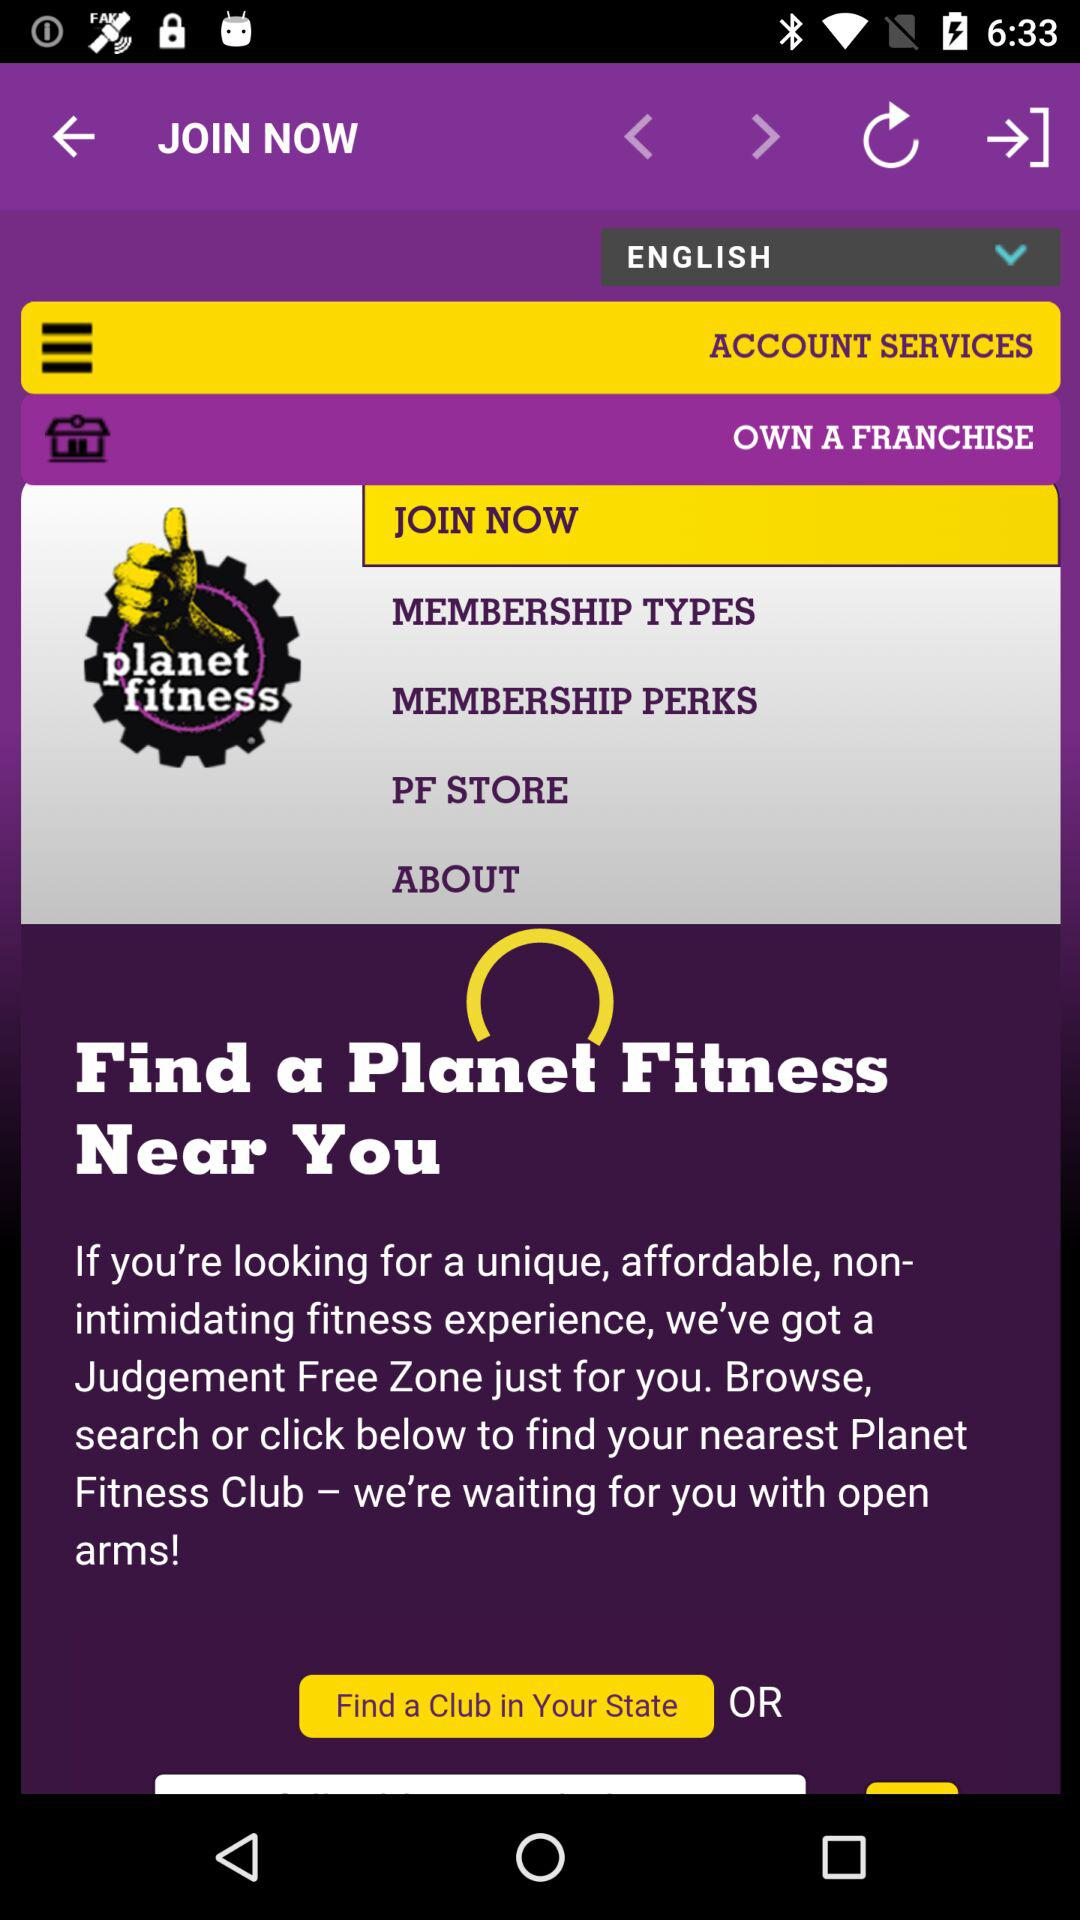Which membership type is selected?
When the provided information is insufficient, respond with <no answer>. <no answer> 